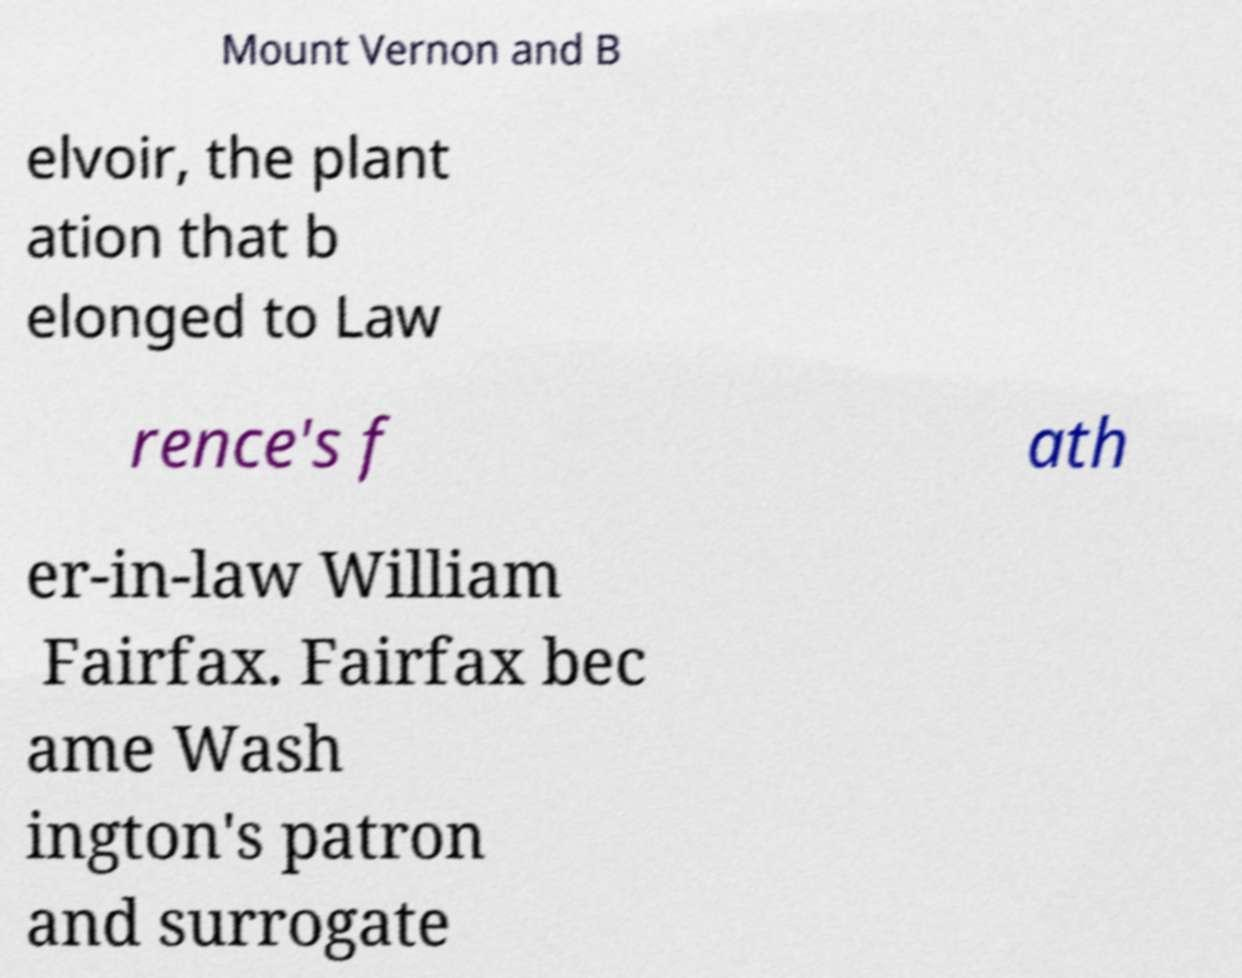Please identify and transcribe the text found in this image. Mount Vernon and B elvoir, the plant ation that b elonged to Law rence's f ath er-in-law William Fairfax. Fairfax bec ame Wash ington's patron and surrogate 